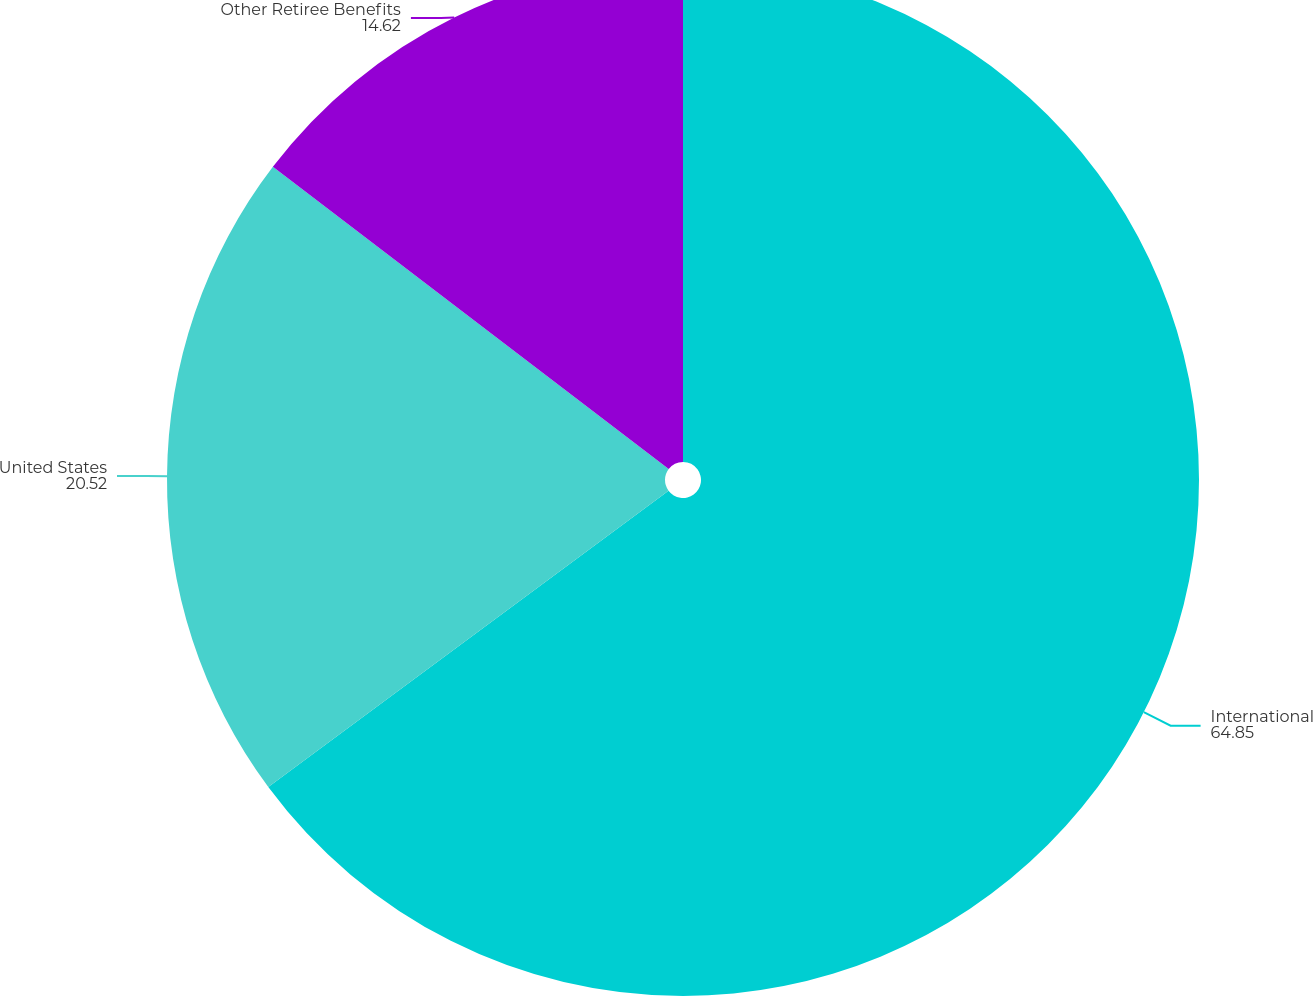Convert chart. <chart><loc_0><loc_0><loc_500><loc_500><pie_chart><fcel>International<fcel>United States<fcel>Other Retiree Benefits<nl><fcel>64.85%<fcel>20.52%<fcel>14.62%<nl></chart> 